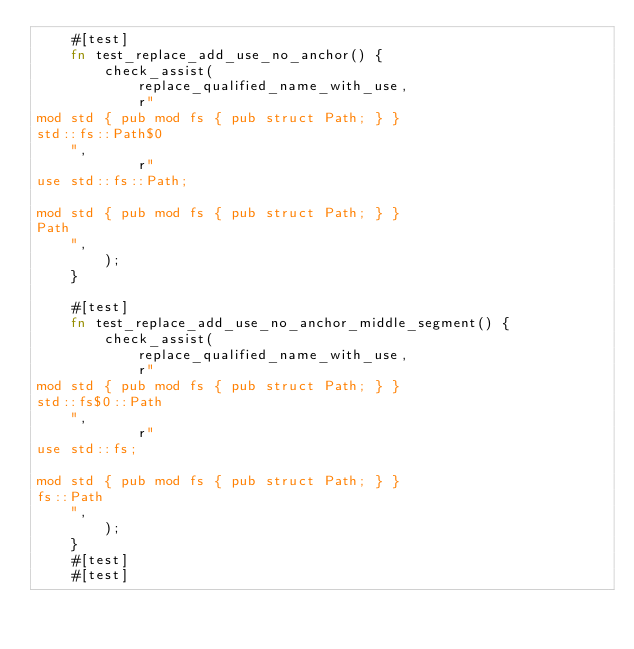<code> <loc_0><loc_0><loc_500><loc_500><_Rust_>    #[test]
    fn test_replace_add_use_no_anchor() {
        check_assist(
            replace_qualified_name_with_use,
            r"
mod std { pub mod fs { pub struct Path; } }
std::fs::Path$0
    ",
            r"
use std::fs::Path;

mod std { pub mod fs { pub struct Path; } }
Path
    ",
        );
    }

    #[test]
    fn test_replace_add_use_no_anchor_middle_segment() {
        check_assist(
            replace_qualified_name_with_use,
            r"
mod std { pub mod fs { pub struct Path; } }
std::fs$0::Path
    ",
            r"
use std::fs;

mod std { pub mod fs { pub struct Path; } }
fs::Path
    ",
        );
    }
    #[test]
    #[test]</code> 